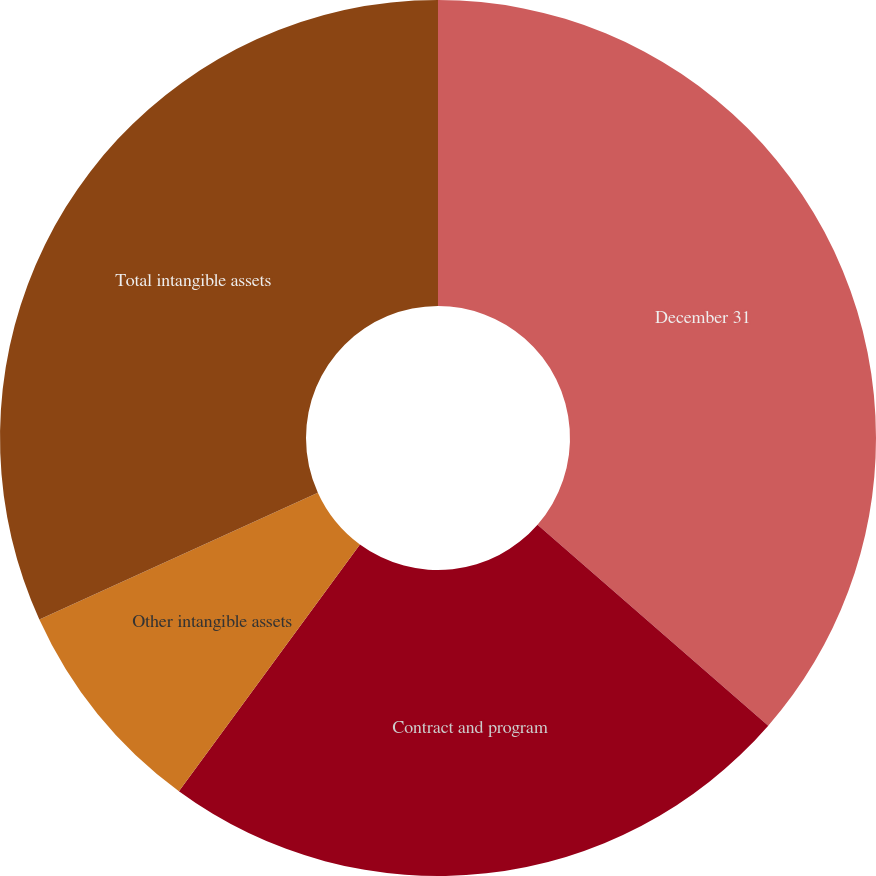Convert chart. <chart><loc_0><loc_0><loc_500><loc_500><pie_chart><fcel>December 31<fcel>Contract and program<fcel>Other intangible assets<fcel>Total intangible assets<nl><fcel>36.41%<fcel>23.67%<fcel>8.13%<fcel>31.8%<nl></chart> 